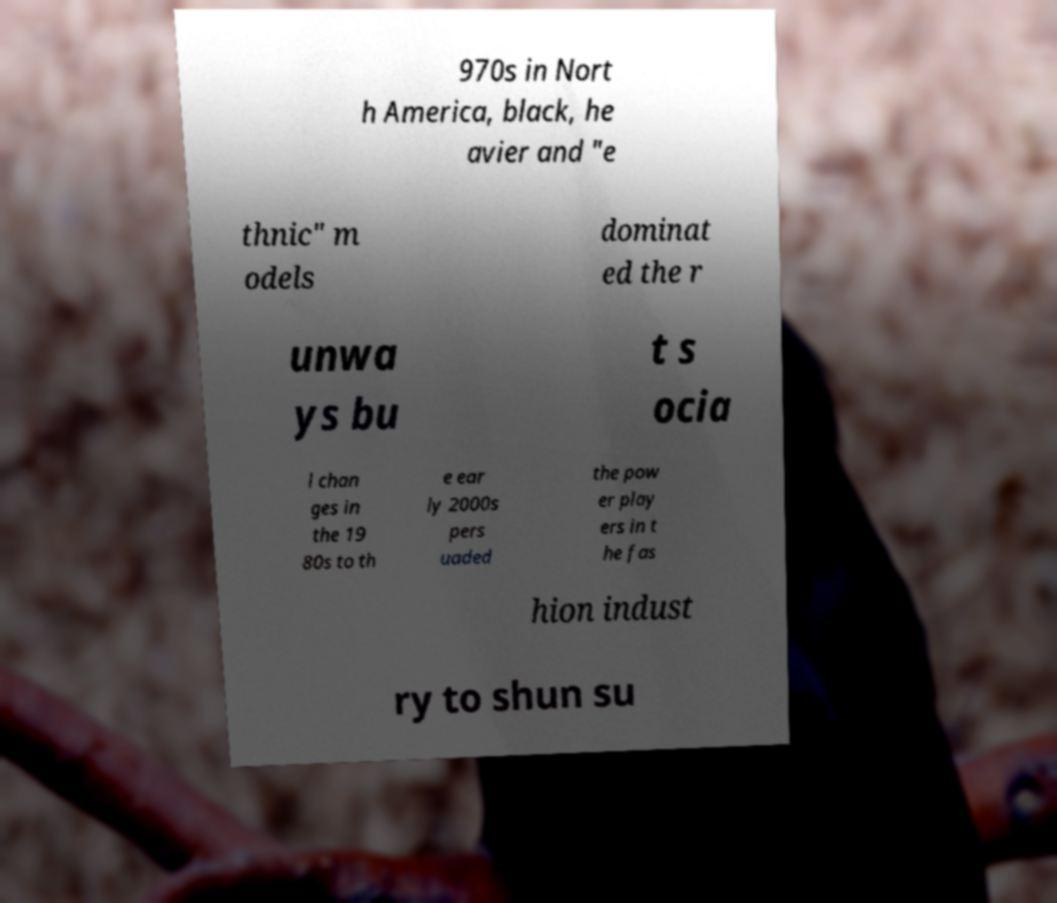Please identify and transcribe the text found in this image. 970s in Nort h America, black, he avier and "e thnic" m odels dominat ed the r unwa ys bu t s ocia l chan ges in the 19 80s to th e ear ly 2000s pers uaded the pow er play ers in t he fas hion indust ry to shun su 